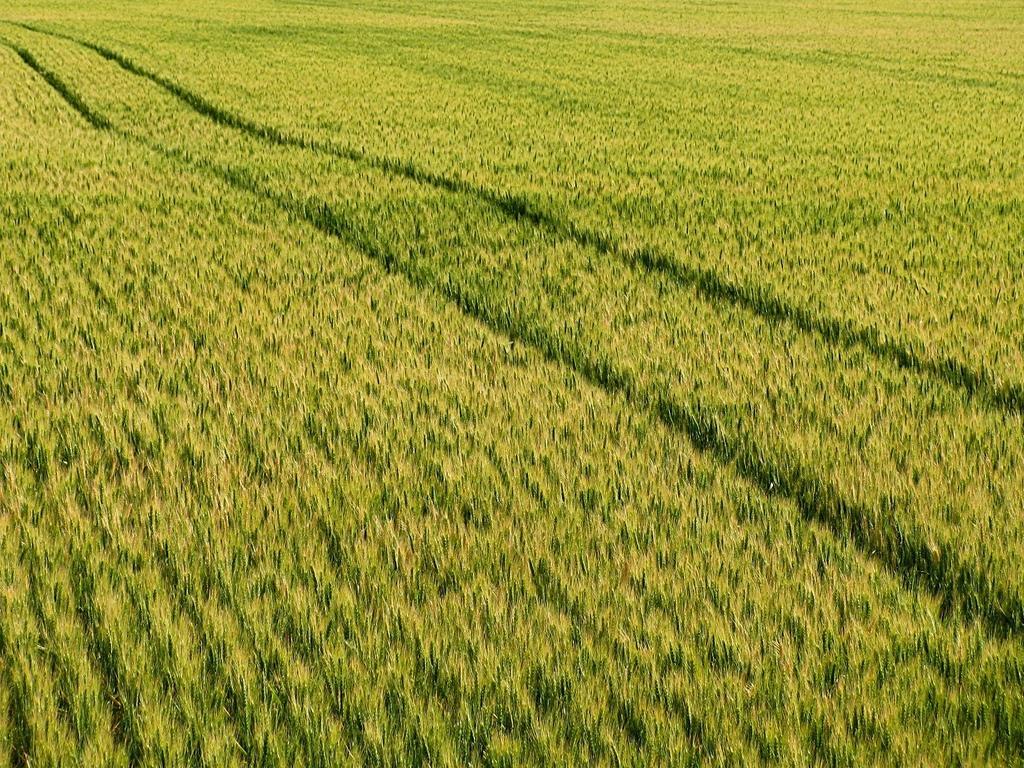Please provide a concise description of this image. This picture is clicked outside the city and we can see the ground is covered with the green grass. 